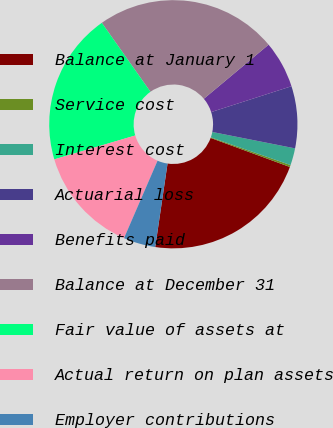Convert chart. <chart><loc_0><loc_0><loc_500><loc_500><pie_chart><fcel>Balance at January 1<fcel>Service cost<fcel>Interest cost<fcel>Actuarial loss<fcel>Benefits paid<fcel>Balance at December 31<fcel>Fair value of assets at<fcel>Actual return on plan assets<fcel>Employer contributions<nl><fcel>21.74%<fcel>0.26%<fcel>2.22%<fcel>8.07%<fcel>6.12%<fcel>23.7%<fcel>19.79%<fcel>13.93%<fcel>4.17%<nl></chart> 